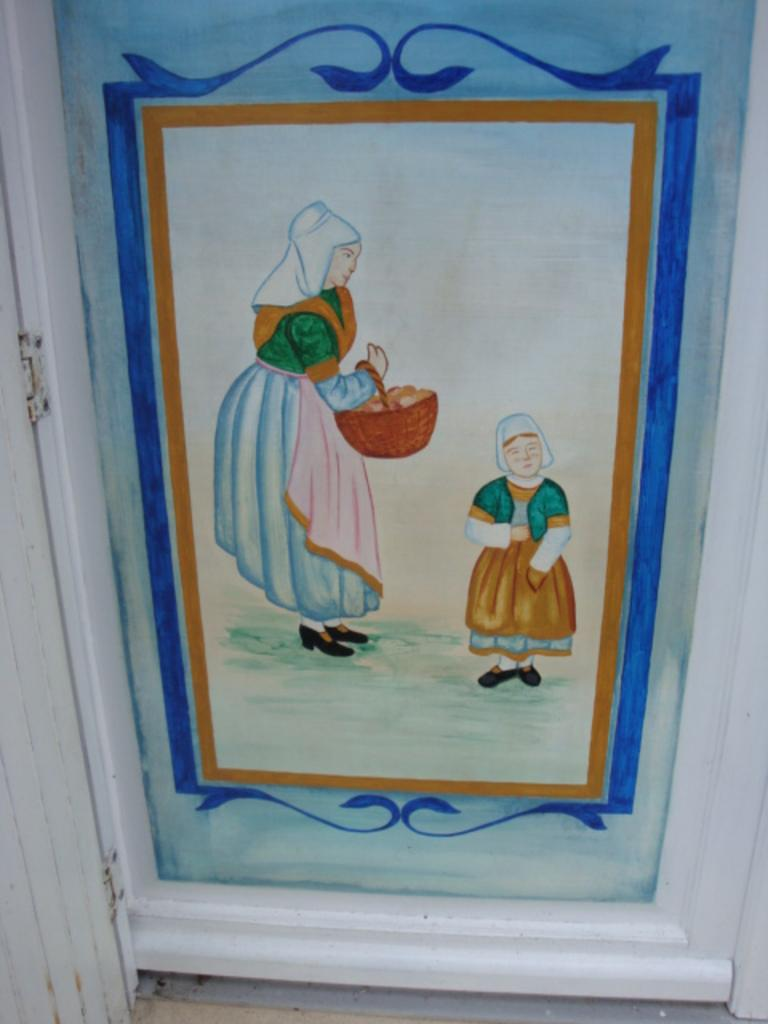What is the main subject in the center of the image? There is a frame in the center of the image. What is inside the frame? The frame contains a painting. What is the subject matter of the painting? The painting depicts a woman and a child. What type of zipper can be seen on the woman's clothing in the painting? There is no zipper visible on the woman's clothing in the painting, as the painting is a two-dimensional representation and does not show details like zippers. 